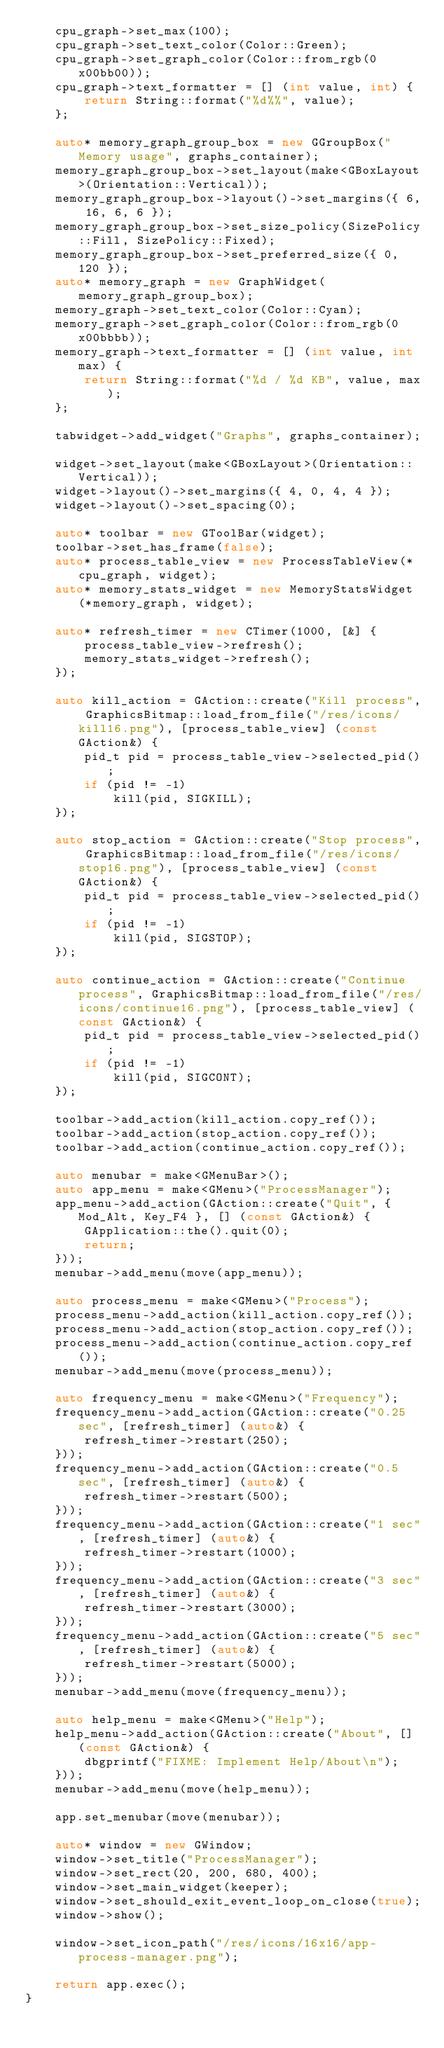<code> <loc_0><loc_0><loc_500><loc_500><_C++_>    cpu_graph->set_max(100);
    cpu_graph->set_text_color(Color::Green);
    cpu_graph->set_graph_color(Color::from_rgb(0x00bb00));
    cpu_graph->text_formatter = [] (int value, int) {
        return String::format("%d%%", value);
    };

    auto* memory_graph_group_box = new GGroupBox("Memory usage", graphs_container);
    memory_graph_group_box->set_layout(make<GBoxLayout>(Orientation::Vertical));
    memory_graph_group_box->layout()->set_margins({ 6, 16, 6, 6 });
    memory_graph_group_box->set_size_policy(SizePolicy::Fill, SizePolicy::Fixed);
    memory_graph_group_box->set_preferred_size({ 0, 120 });
    auto* memory_graph = new GraphWidget(memory_graph_group_box);
    memory_graph->set_text_color(Color::Cyan);
    memory_graph->set_graph_color(Color::from_rgb(0x00bbbb));
    memory_graph->text_formatter = [] (int value, int max) {
        return String::format("%d / %d KB", value, max);
    };

    tabwidget->add_widget("Graphs", graphs_container);

    widget->set_layout(make<GBoxLayout>(Orientation::Vertical));
    widget->layout()->set_margins({ 4, 0, 4, 4 });
    widget->layout()->set_spacing(0);

    auto* toolbar = new GToolBar(widget);
    toolbar->set_has_frame(false);
    auto* process_table_view = new ProcessTableView(*cpu_graph, widget);
    auto* memory_stats_widget = new MemoryStatsWidget(*memory_graph, widget);

    auto* refresh_timer = new CTimer(1000, [&] {
        process_table_view->refresh();
        memory_stats_widget->refresh();
    });

    auto kill_action = GAction::create("Kill process", GraphicsBitmap::load_from_file("/res/icons/kill16.png"), [process_table_view] (const GAction&) {
        pid_t pid = process_table_view->selected_pid();
        if (pid != -1)
            kill(pid, SIGKILL);
    });

    auto stop_action = GAction::create("Stop process", GraphicsBitmap::load_from_file("/res/icons/stop16.png"), [process_table_view] (const GAction&) {
        pid_t pid = process_table_view->selected_pid();
        if (pid != -1)
            kill(pid, SIGSTOP);
    });

    auto continue_action = GAction::create("Continue process", GraphicsBitmap::load_from_file("/res/icons/continue16.png"), [process_table_view] (const GAction&) {
        pid_t pid = process_table_view->selected_pid();
        if (pid != -1)
            kill(pid, SIGCONT);
    });

    toolbar->add_action(kill_action.copy_ref());
    toolbar->add_action(stop_action.copy_ref());
    toolbar->add_action(continue_action.copy_ref());

    auto menubar = make<GMenuBar>();
    auto app_menu = make<GMenu>("ProcessManager");
    app_menu->add_action(GAction::create("Quit", { Mod_Alt, Key_F4 }, [] (const GAction&) {
        GApplication::the().quit(0);
        return;
    }));
    menubar->add_menu(move(app_menu));

    auto process_menu = make<GMenu>("Process");
    process_menu->add_action(kill_action.copy_ref());
    process_menu->add_action(stop_action.copy_ref());
    process_menu->add_action(continue_action.copy_ref());
    menubar->add_menu(move(process_menu));

    auto frequency_menu = make<GMenu>("Frequency");
    frequency_menu->add_action(GAction::create("0.25 sec", [refresh_timer] (auto&) {
        refresh_timer->restart(250);
    }));
    frequency_menu->add_action(GAction::create("0.5 sec", [refresh_timer] (auto&) {
        refresh_timer->restart(500);
    }));
    frequency_menu->add_action(GAction::create("1 sec", [refresh_timer] (auto&) {
        refresh_timer->restart(1000);
    }));
    frequency_menu->add_action(GAction::create("3 sec", [refresh_timer] (auto&) {
        refresh_timer->restart(3000);
    }));
    frequency_menu->add_action(GAction::create("5 sec", [refresh_timer] (auto&) {
        refresh_timer->restart(5000);
    }));
    menubar->add_menu(move(frequency_menu));

    auto help_menu = make<GMenu>("Help");
    help_menu->add_action(GAction::create("About", [] (const GAction&) {
        dbgprintf("FIXME: Implement Help/About\n");
    }));
    menubar->add_menu(move(help_menu));

    app.set_menubar(move(menubar));

    auto* window = new GWindow;
    window->set_title("ProcessManager");
    window->set_rect(20, 200, 680, 400);
    window->set_main_widget(keeper);
    window->set_should_exit_event_loop_on_close(true);
    window->show();

    window->set_icon_path("/res/icons/16x16/app-process-manager.png");

    return app.exec();
}
</code> 